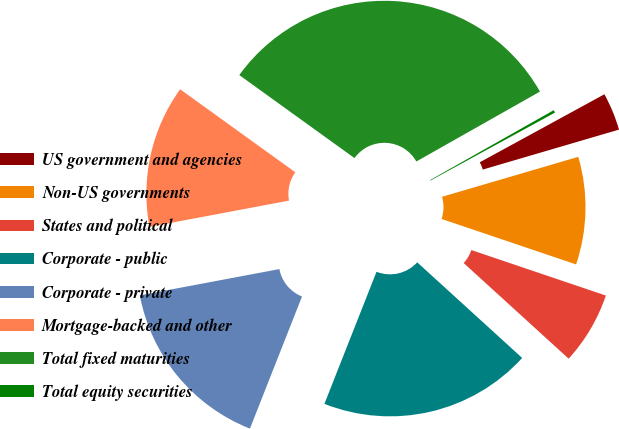Convert chart to OTSL. <chart><loc_0><loc_0><loc_500><loc_500><pie_chart><fcel>US government and agencies<fcel>Non-US governments<fcel>States and political<fcel>Corporate - public<fcel>Corporate - private<fcel>Mortgage-backed and other<fcel>Total fixed maturities<fcel>Total equity securities<nl><fcel>3.41%<fcel>9.73%<fcel>6.57%<fcel>19.22%<fcel>16.06%<fcel>12.9%<fcel>31.87%<fcel>0.24%<nl></chart> 